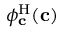<formula> <loc_0><loc_0><loc_500><loc_500>\phi _ { c } ^ { H } ( c )</formula> 